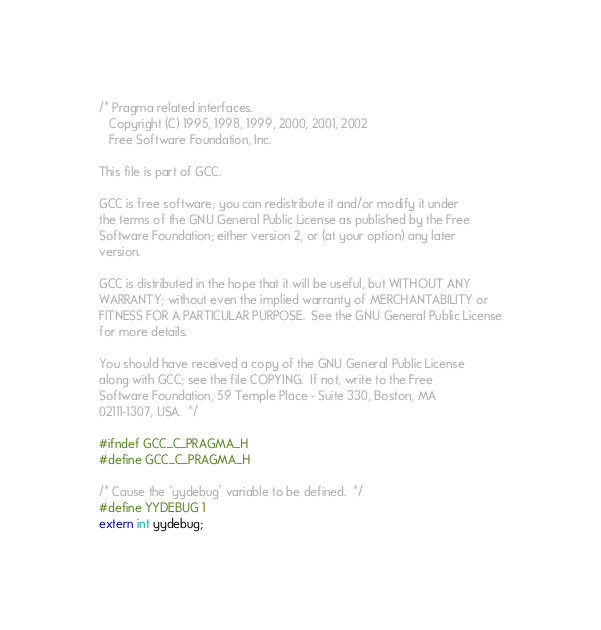<code> <loc_0><loc_0><loc_500><loc_500><_C_>/* Pragma related interfaces.
   Copyright (C) 1995, 1998, 1999, 2000, 2001, 2002
   Free Software Foundation, Inc.

This file is part of GCC.

GCC is free software; you can redistribute it and/or modify it under
the terms of the GNU General Public License as published by the Free
Software Foundation; either version 2, or (at your option) any later
version.

GCC is distributed in the hope that it will be useful, but WITHOUT ANY
WARRANTY; without even the implied warranty of MERCHANTABILITY or
FITNESS FOR A PARTICULAR PURPOSE.  See the GNU General Public License
for more details.

You should have received a copy of the GNU General Public License
along with GCC; see the file COPYING.  If not, write to the Free
Software Foundation, 59 Temple Place - Suite 330, Boston, MA
02111-1307, USA.  */

#ifndef GCC_C_PRAGMA_H
#define GCC_C_PRAGMA_H

/* Cause the `yydebug' variable to be defined.  */
#define YYDEBUG 1
extern int yydebug;
</code> 